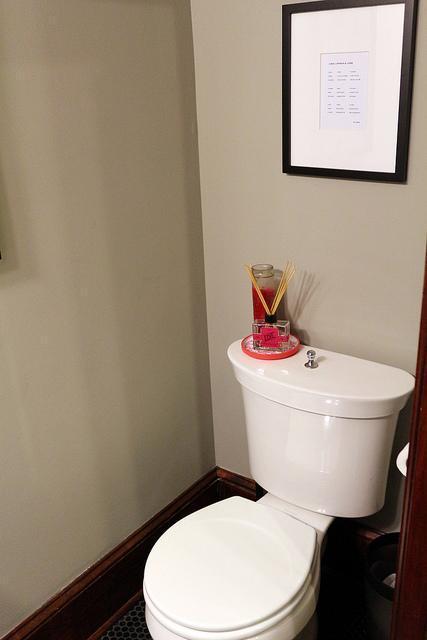How many toilets are there?
Give a very brief answer. 2. 